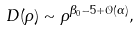Convert formula to latex. <formula><loc_0><loc_0><loc_500><loc_500>D ( { \rho } ) \sim \rho ^ { \beta _ { 0 } - 5 + \mathcal { O } ( \alpha ) } ,</formula> 